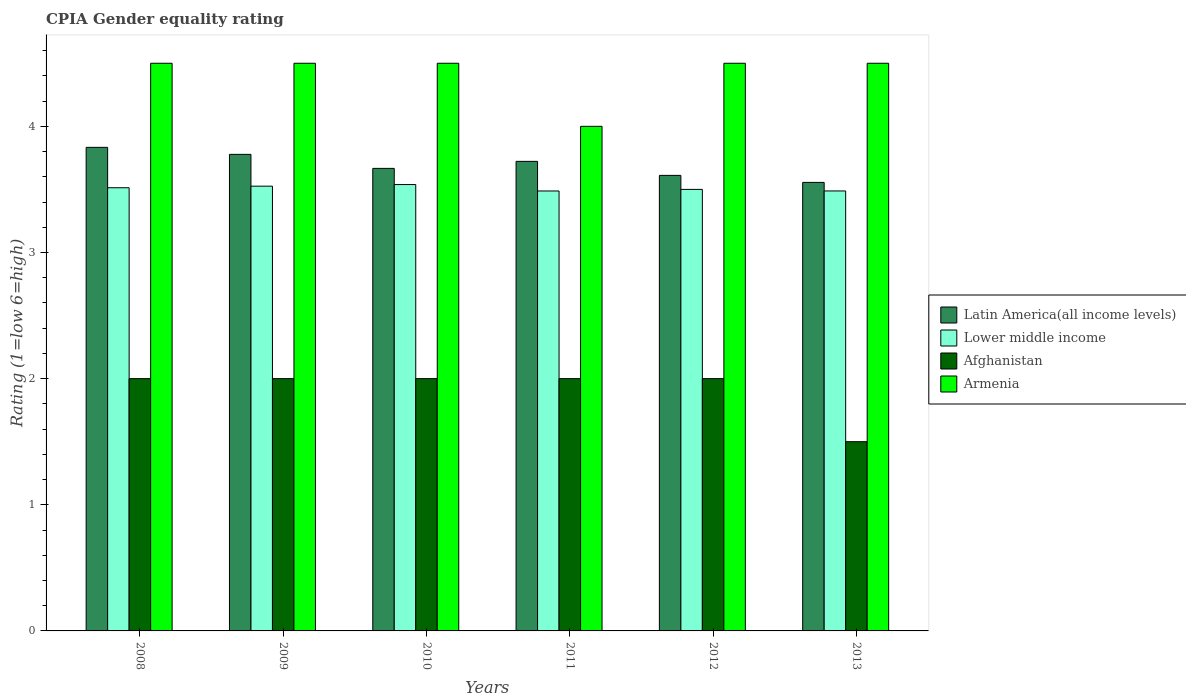How many different coloured bars are there?
Your response must be concise. 4. How many groups of bars are there?
Your answer should be compact. 6. Are the number of bars on each tick of the X-axis equal?
Keep it short and to the point. Yes. How many bars are there on the 4th tick from the left?
Give a very brief answer. 4. How many bars are there on the 4th tick from the right?
Provide a short and direct response. 4. What is the CPIA rating in Latin America(all income levels) in 2009?
Make the answer very short. 3.78. Across all years, what is the maximum CPIA rating in Latin America(all income levels)?
Provide a short and direct response. 3.83. In which year was the CPIA rating in Lower middle income maximum?
Give a very brief answer. 2010. In which year was the CPIA rating in Latin America(all income levels) minimum?
Provide a succinct answer. 2013. What is the total CPIA rating in Afghanistan in the graph?
Provide a succinct answer. 11.5. What is the difference between the CPIA rating in Latin America(all income levels) in 2011 and the CPIA rating in Lower middle income in 2013?
Your answer should be compact. 0.23. What is the average CPIA rating in Armenia per year?
Offer a terse response. 4.42. In the year 2010, what is the difference between the CPIA rating in Latin America(all income levels) and CPIA rating in Afghanistan?
Keep it short and to the point. 1.67. What is the ratio of the CPIA rating in Lower middle income in 2010 to that in 2012?
Your answer should be very brief. 1.01. What is the difference between the highest and the lowest CPIA rating in Afghanistan?
Provide a short and direct response. 0.5. What does the 2nd bar from the left in 2008 represents?
Offer a very short reply. Lower middle income. What does the 2nd bar from the right in 2009 represents?
Your answer should be very brief. Afghanistan. Is it the case that in every year, the sum of the CPIA rating in Lower middle income and CPIA rating in Latin America(all income levels) is greater than the CPIA rating in Armenia?
Provide a succinct answer. Yes. Are all the bars in the graph horizontal?
Make the answer very short. No. What is the difference between two consecutive major ticks on the Y-axis?
Your answer should be very brief. 1. Does the graph contain any zero values?
Your response must be concise. No. Does the graph contain grids?
Keep it short and to the point. No. Where does the legend appear in the graph?
Provide a short and direct response. Center right. How many legend labels are there?
Your response must be concise. 4. What is the title of the graph?
Provide a succinct answer. CPIA Gender equality rating. What is the label or title of the X-axis?
Your response must be concise. Years. What is the Rating (1=low 6=high) in Latin America(all income levels) in 2008?
Your response must be concise. 3.83. What is the Rating (1=low 6=high) of Lower middle income in 2008?
Keep it short and to the point. 3.51. What is the Rating (1=low 6=high) of Armenia in 2008?
Offer a very short reply. 4.5. What is the Rating (1=low 6=high) in Latin America(all income levels) in 2009?
Give a very brief answer. 3.78. What is the Rating (1=low 6=high) in Lower middle income in 2009?
Keep it short and to the point. 3.53. What is the Rating (1=low 6=high) of Armenia in 2009?
Ensure brevity in your answer.  4.5. What is the Rating (1=low 6=high) of Latin America(all income levels) in 2010?
Make the answer very short. 3.67. What is the Rating (1=low 6=high) in Lower middle income in 2010?
Your answer should be very brief. 3.54. What is the Rating (1=low 6=high) of Afghanistan in 2010?
Provide a succinct answer. 2. What is the Rating (1=low 6=high) in Latin America(all income levels) in 2011?
Make the answer very short. 3.72. What is the Rating (1=low 6=high) in Lower middle income in 2011?
Offer a very short reply. 3.49. What is the Rating (1=low 6=high) in Afghanistan in 2011?
Give a very brief answer. 2. What is the Rating (1=low 6=high) of Armenia in 2011?
Make the answer very short. 4. What is the Rating (1=low 6=high) in Latin America(all income levels) in 2012?
Offer a terse response. 3.61. What is the Rating (1=low 6=high) in Lower middle income in 2012?
Your answer should be very brief. 3.5. What is the Rating (1=low 6=high) in Afghanistan in 2012?
Make the answer very short. 2. What is the Rating (1=low 6=high) in Latin America(all income levels) in 2013?
Provide a short and direct response. 3.56. What is the Rating (1=low 6=high) of Lower middle income in 2013?
Ensure brevity in your answer.  3.49. Across all years, what is the maximum Rating (1=low 6=high) of Latin America(all income levels)?
Make the answer very short. 3.83. Across all years, what is the maximum Rating (1=low 6=high) in Lower middle income?
Offer a very short reply. 3.54. Across all years, what is the minimum Rating (1=low 6=high) in Latin America(all income levels)?
Your response must be concise. 3.56. Across all years, what is the minimum Rating (1=low 6=high) in Lower middle income?
Offer a very short reply. 3.49. Across all years, what is the minimum Rating (1=low 6=high) of Armenia?
Keep it short and to the point. 4. What is the total Rating (1=low 6=high) of Latin America(all income levels) in the graph?
Ensure brevity in your answer.  22.17. What is the total Rating (1=low 6=high) of Lower middle income in the graph?
Give a very brief answer. 21.05. What is the difference between the Rating (1=low 6=high) in Latin America(all income levels) in 2008 and that in 2009?
Your answer should be compact. 0.06. What is the difference between the Rating (1=low 6=high) in Lower middle income in 2008 and that in 2009?
Give a very brief answer. -0.01. What is the difference between the Rating (1=low 6=high) in Armenia in 2008 and that in 2009?
Your response must be concise. 0. What is the difference between the Rating (1=low 6=high) in Lower middle income in 2008 and that in 2010?
Give a very brief answer. -0.03. What is the difference between the Rating (1=low 6=high) in Afghanistan in 2008 and that in 2010?
Your answer should be very brief. 0. What is the difference between the Rating (1=low 6=high) in Lower middle income in 2008 and that in 2011?
Your response must be concise. 0.03. What is the difference between the Rating (1=low 6=high) of Latin America(all income levels) in 2008 and that in 2012?
Offer a terse response. 0.22. What is the difference between the Rating (1=low 6=high) of Lower middle income in 2008 and that in 2012?
Provide a short and direct response. 0.01. What is the difference between the Rating (1=low 6=high) in Afghanistan in 2008 and that in 2012?
Your answer should be very brief. 0. What is the difference between the Rating (1=low 6=high) in Latin America(all income levels) in 2008 and that in 2013?
Your answer should be compact. 0.28. What is the difference between the Rating (1=low 6=high) of Lower middle income in 2008 and that in 2013?
Ensure brevity in your answer.  0.03. What is the difference between the Rating (1=low 6=high) in Afghanistan in 2008 and that in 2013?
Make the answer very short. 0.5. What is the difference between the Rating (1=low 6=high) of Latin America(all income levels) in 2009 and that in 2010?
Make the answer very short. 0.11. What is the difference between the Rating (1=low 6=high) of Lower middle income in 2009 and that in 2010?
Provide a short and direct response. -0.01. What is the difference between the Rating (1=low 6=high) in Armenia in 2009 and that in 2010?
Your response must be concise. 0. What is the difference between the Rating (1=low 6=high) in Latin America(all income levels) in 2009 and that in 2011?
Give a very brief answer. 0.06. What is the difference between the Rating (1=low 6=high) of Lower middle income in 2009 and that in 2011?
Give a very brief answer. 0.04. What is the difference between the Rating (1=low 6=high) of Afghanistan in 2009 and that in 2011?
Keep it short and to the point. 0. What is the difference between the Rating (1=low 6=high) of Latin America(all income levels) in 2009 and that in 2012?
Ensure brevity in your answer.  0.17. What is the difference between the Rating (1=low 6=high) in Lower middle income in 2009 and that in 2012?
Your answer should be very brief. 0.03. What is the difference between the Rating (1=low 6=high) of Armenia in 2009 and that in 2012?
Offer a terse response. 0. What is the difference between the Rating (1=low 6=high) of Latin America(all income levels) in 2009 and that in 2013?
Your answer should be very brief. 0.22. What is the difference between the Rating (1=low 6=high) in Lower middle income in 2009 and that in 2013?
Your response must be concise. 0.04. What is the difference between the Rating (1=low 6=high) of Afghanistan in 2009 and that in 2013?
Provide a succinct answer. 0.5. What is the difference between the Rating (1=low 6=high) in Armenia in 2009 and that in 2013?
Keep it short and to the point. 0. What is the difference between the Rating (1=low 6=high) of Latin America(all income levels) in 2010 and that in 2011?
Provide a short and direct response. -0.06. What is the difference between the Rating (1=low 6=high) of Lower middle income in 2010 and that in 2011?
Provide a short and direct response. 0.05. What is the difference between the Rating (1=low 6=high) in Armenia in 2010 and that in 2011?
Provide a short and direct response. 0.5. What is the difference between the Rating (1=low 6=high) in Latin America(all income levels) in 2010 and that in 2012?
Provide a succinct answer. 0.06. What is the difference between the Rating (1=low 6=high) in Lower middle income in 2010 and that in 2012?
Offer a very short reply. 0.04. What is the difference between the Rating (1=low 6=high) of Afghanistan in 2010 and that in 2012?
Give a very brief answer. 0. What is the difference between the Rating (1=low 6=high) in Lower middle income in 2010 and that in 2013?
Offer a very short reply. 0.05. What is the difference between the Rating (1=low 6=high) in Armenia in 2010 and that in 2013?
Give a very brief answer. 0. What is the difference between the Rating (1=low 6=high) in Latin America(all income levels) in 2011 and that in 2012?
Provide a short and direct response. 0.11. What is the difference between the Rating (1=low 6=high) of Lower middle income in 2011 and that in 2012?
Keep it short and to the point. -0.01. What is the difference between the Rating (1=low 6=high) in Armenia in 2011 and that in 2012?
Make the answer very short. -0.5. What is the difference between the Rating (1=low 6=high) in Latin America(all income levels) in 2011 and that in 2013?
Your response must be concise. 0.17. What is the difference between the Rating (1=low 6=high) in Lower middle income in 2011 and that in 2013?
Ensure brevity in your answer.  -0. What is the difference between the Rating (1=low 6=high) of Afghanistan in 2011 and that in 2013?
Offer a very short reply. 0.5. What is the difference between the Rating (1=low 6=high) in Latin America(all income levels) in 2012 and that in 2013?
Give a very brief answer. 0.06. What is the difference between the Rating (1=low 6=high) in Lower middle income in 2012 and that in 2013?
Give a very brief answer. 0.01. What is the difference between the Rating (1=low 6=high) of Afghanistan in 2012 and that in 2013?
Offer a very short reply. 0.5. What is the difference between the Rating (1=low 6=high) of Latin America(all income levels) in 2008 and the Rating (1=low 6=high) of Lower middle income in 2009?
Ensure brevity in your answer.  0.31. What is the difference between the Rating (1=low 6=high) in Latin America(all income levels) in 2008 and the Rating (1=low 6=high) in Afghanistan in 2009?
Provide a short and direct response. 1.83. What is the difference between the Rating (1=low 6=high) in Lower middle income in 2008 and the Rating (1=low 6=high) in Afghanistan in 2009?
Your response must be concise. 1.51. What is the difference between the Rating (1=low 6=high) in Lower middle income in 2008 and the Rating (1=low 6=high) in Armenia in 2009?
Your answer should be very brief. -0.99. What is the difference between the Rating (1=low 6=high) of Latin America(all income levels) in 2008 and the Rating (1=low 6=high) of Lower middle income in 2010?
Ensure brevity in your answer.  0.29. What is the difference between the Rating (1=low 6=high) in Latin America(all income levels) in 2008 and the Rating (1=low 6=high) in Afghanistan in 2010?
Ensure brevity in your answer.  1.83. What is the difference between the Rating (1=low 6=high) in Lower middle income in 2008 and the Rating (1=low 6=high) in Afghanistan in 2010?
Give a very brief answer. 1.51. What is the difference between the Rating (1=low 6=high) in Lower middle income in 2008 and the Rating (1=low 6=high) in Armenia in 2010?
Make the answer very short. -0.99. What is the difference between the Rating (1=low 6=high) in Latin America(all income levels) in 2008 and the Rating (1=low 6=high) in Lower middle income in 2011?
Your answer should be compact. 0.35. What is the difference between the Rating (1=low 6=high) of Latin America(all income levels) in 2008 and the Rating (1=low 6=high) of Afghanistan in 2011?
Provide a succinct answer. 1.83. What is the difference between the Rating (1=low 6=high) of Latin America(all income levels) in 2008 and the Rating (1=low 6=high) of Armenia in 2011?
Make the answer very short. -0.17. What is the difference between the Rating (1=low 6=high) in Lower middle income in 2008 and the Rating (1=low 6=high) in Afghanistan in 2011?
Give a very brief answer. 1.51. What is the difference between the Rating (1=low 6=high) of Lower middle income in 2008 and the Rating (1=low 6=high) of Armenia in 2011?
Your answer should be compact. -0.49. What is the difference between the Rating (1=low 6=high) of Afghanistan in 2008 and the Rating (1=low 6=high) of Armenia in 2011?
Provide a short and direct response. -2. What is the difference between the Rating (1=low 6=high) in Latin America(all income levels) in 2008 and the Rating (1=low 6=high) in Lower middle income in 2012?
Keep it short and to the point. 0.33. What is the difference between the Rating (1=low 6=high) in Latin America(all income levels) in 2008 and the Rating (1=low 6=high) in Afghanistan in 2012?
Ensure brevity in your answer.  1.83. What is the difference between the Rating (1=low 6=high) of Lower middle income in 2008 and the Rating (1=low 6=high) of Afghanistan in 2012?
Keep it short and to the point. 1.51. What is the difference between the Rating (1=low 6=high) in Lower middle income in 2008 and the Rating (1=low 6=high) in Armenia in 2012?
Your answer should be compact. -0.99. What is the difference between the Rating (1=low 6=high) in Afghanistan in 2008 and the Rating (1=low 6=high) in Armenia in 2012?
Offer a terse response. -2.5. What is the difference between the Rating (1=low 6=high) of Latin America(all income levels) in 2008 and the Rating (1=low 6=high) of Lower middle income in 2013?
Your answer should be very brief. 0.35. What is the difference between the Rating (1=low 6=high) of Latin America(all income levels) in 2008 and the Rating (1=low 6=high) of Afghanistan in 2013?
Give a very brief answer. 2.33. What is the difference between the Rating (1=low 6=high) in Latin America(all income levels) in 2008 and the Rating (1=low 6=high) in Armenia in 2013?
Give a very brief answer. -0.67. What is the difference between the Rating (1=low 6=high) of Lower middle income in 2008 and the Rating (1=low 6=high) of Afghanistan in 2013?
Your answer should be compact. 2.01. What is the difference between the Rating (1=low 6=high) of Lower middle income in 2008 and the Rating (1=low 6=high) of Armenia in 2013?
Provide a short and direct response. -0.99. What is the difference between the Rating (1=low 6=high) of Afghanistan in 2008 and the Rating (1=low 6=high) of Armenia in 2013?
Offer a very short reply. -2.5. What is the difference between the Rating (1=low 6=high) of Latin America(all income levels) in 2009 and the Rating (1=low 6=high) of Lower middle income in 2010?
Ensure brevity in your answer.  0.24. What is the difference between the Rating (1=low 6=high) in Latin America(all income levels) in 2009 and the Rating (1=low 6=high) in Afghanistan in 2010?
Provide a short and direct response. 1.78. What is the difference between the Rating (1=low 6=high) of Latin America(all income levels) in 2009 and the Rating (1=low 6=high) of Armenia in 2010?
Your response must be concise. -0.72. What is the difference between the Rating (1=low 6=high) of Lower middle income in 2009 and the Rating (1=low 6=high) of Afghanistan in 2010?
Your answer should be very brief. 1.53. What is the difference between the Rating (1=low 6=high) in Lower middle income in 2009 and the Rating (1=low 6=high) in Armenia in 2010?
Your response must be concise. -0.97. What is the difference between the Rating (1=low 6=high) in Latin America(all income levels) in 2009 and the Rating (1=low 6=high) in Lower middle income in 2011?
Make the answer very short. 0.29. What is the difference between the Rating (1=low 6=high) in Latin America(all income levels) in 2009 and the Rating (1=low 6=high) in Afghanistan in 2011?
Offer a terse response. 1.78. What is the difference between the Rating (1=low 6=high) in Latin America(all income levels) in 2009 and the Rating (1=low 6=high) in Armenia in 2011?
Give a very brief answer. -0.22. What is the difference between the Rating (1=low 6=high) of Lower middle income in 2009 and the Rating (1=low 6=high) of Afghanistan in 2011?
Make the answer very short. 1.53. What is the difference between the Rating (1=low 6=high) of Lower middle income in 2009 and the Rating (1=low 6=high) of Armenia in 2011?
Keep it short and to the point. -0.47. What is the difference between the Rating (1=low 6=high) in Latin America(all income levels) in 2009 and the Rating (1=low 6=high) in Lower middle income in 2012?
Your response must be concise. 0.28. What is the difference between the Rating (1=low 6=high) of Latin America(all income levels) in 2009 and the Rating (1=low 6=high) of Afghanistan in 2012?
Your response must be concise. 1.78. What is the difference between the Rating (1=low 6=high) of Latin America(all income levels) in 2009 and the Rating (1=low 6=high) of Armenia in 2012?
Your response must be concise. -0.72. What is the difference between the Rating (1=low 6=high) in Lower middle income in 2009 and the Rating (1=low 6=high) in Afghanistan in 2012?
Offer a terse response. 1.53. What is the difference between the Rating (1=low 6=high) in Lower middle income in 2009 and the Rating (1=low 6=high) in Armenia in 2012?
Keep it short and to the point. -0.97. What is the difference between the Rating (1=low 6=high) of Latin America(all income levels) in 2009 and the Rating (1=low 6=high) of Lower middle income in 2013?
Make the answer very short. 0.29. What is the difference between the Rating (1=low 6=high) of Latin America(all income levels) in 2009 and the Rating (1=low 6=high) of Afghanistan in 2013?
Keep it short and to the point. 2.28. What is the difference between the Rating (1=low 6=high) of Latin America(all income levels) in 2009 and the Rating (1=low 6=high) of Armenia in 2013?
Offer a very short reply. -0.72. What is the difference between the Rating (1=low 6=high) of Lower middle income in 2009 and the Rating (1=low 6=high) of Afghanistan in 2013?
Ensure brevity in your answer.  2.03. What is the difference between the Rating (1=low 6=high) in Lower middle income in 2009 and the Rating (1=low 6=high) in Armenia in 2013?
Your answer should be compact. -0.97. What is the difference between the Rating (1=low 6=high) in Latin America(all income levels) in 2010 and the Rating (1=low 6=high) in Lower middle income in 2011?
Your response must be concise. 0.18. What is the difference between the Rating (1=low 6=high) of Latin America(all income levels) in 2010 and the Rating (1=low 6=high) of Afghanistan in 2011?
Offer a very short reply. 1.67. What is the difference between the Rating (1=low 6=high) of Latin America(all income levels) in 2010 and the Rating (1=low 6=high) of Armenia in 2011?
Give a very brief answer. -0.33. What is the difference between the Rating (1=low 6=high) in Lower middle income in 2010 and the Rating (1=low 6=high) in Afghanistan in 2011?
Make the answer very short. 1.54. What is the difference between the Rating (1=low 6=high) of Lower middle income in 2010 and the Rating (1=low 6=high) of Armenia in 2011?
Your answer should be very brief. -0.46. What is the difference between the Rating (1=low 6=high) of Latin America(all income levels) in 2010 and the Rating (1=low 6=high) of Afghanistan in 2012?
Make the answer very short. 1.67. What is the difference between the Rating (1=low 6=high) in Lower middle income in 2010 and the Rating (1=low 6=high) in Afghanistan in 2012?
Provide a succinct answer. 1.54. What is the difference between the Rating (1=low 6=high) in Lower middle income in 2010 and the Rating (1=low 6=high) in Armenia in 2012?
Provide a succinct answer. -0.96. What is the difference between the Rating (1=low 6=high) of Latin America(all income levels) in 2010 and the Rating (1=low 6=high) of Lower middle income in 2013?
Offer a very short reply. 0.18. What is the difference between the Rating (1=low 6=high) in Latin America(all income levels) in 2010 and the Rating (1=low 6=high) in Afghanistan in 2013?
Your answer should be very brief. 2.17. What is the difference between the Rating (1=low 6=high) in Latin America(all income levels) in 2010 and the Rating (1=low 6=high) in Armenia in 2013?
Keep it short and to the point. -0.83. What is the difference between the Rating (1=low 6=high) of Lower middle income in 2010 and the Rating (1=low 6=high) of Afghanistan in 2013?
Keep it short and to the point. 2.04. What is the difference between the Rating (1=low 6=high) in Lower middle income in 2010 and the Rating (1=low 6=high) in Armenia in 2013?
Offer a terse response. -0.96. What is the difference between the Rating (1=low 6=high) of Latin America(all income levels) in 2011 and the Rating (1=low 6=high) of Lower middle income in 2012?
Provide a succinct answer. 0.22. What is the difference between the Rating (1=low 6=high) of Latin America(all income levels) in 2011 and the Rating (1=low 6=high) of Afghanistan in 2012?
Your answer should be compact. 1.72. What is the difference between the Rating (1=low 6=high) in Latin America(all income levels) in 2011 and the Rating (1=low 6=high) in Armenia in 2012?
Give a very brief answer. -0.78. What is the difference between the Rating (1=low 6=high) in Lower middle income in 2011 and the Rating (1=low 6=high) in Afghanistan in 2012?
Keep it short and to the point. 1.49. What is the difference between the Rating (1=low 6=high) in Lower middle income in 2011 and the Rating (1=low 6=high) in Armenia in 2012?
Offer a terse response. -1.01. What is the difference between the Rating (1=low 6=high) of Afghanistan in 2011 and the Rating (1=low 6=high) of Armenia in 2012?
Your answer should be compact. -2.5. What is the difference between the Rating (1=low 6=high) of Latin America(all income levels) in 2011 and the Rating (1=low 6=high) of Lower middle income in 2013?
Offer a very short reply. 0.23. What is the difference between the Rating (1=low 6=high) in Latin America(all income levels) in 2011 and the Rating (1=low 6=high) in Afghanistan in 2013?
Ensure brevity in your answer.  2.22. What is the difference between the Rating (1=low 6=high) of Latin America(all income levels) in 2011 and the Rating (1=low 6=high) of Armenia in 2013?
Ensure brevity in your answer.  -0.78. What is the difference between the Rating (1=low 6=high) in Lower middle income in 2011 and the Rating (1=low 6=high) in Afghanistan in 2013?
Ensure brevity in your answer.  1.99. What is the difference between the Rating (1=low 6=high) in Lower middle income in 2011 and the Rating (1=low 6=high) in Armenia in 2013?
Your answer should be compact. -1.01. What is the difference between the Rating (1=low 6=high) of Afghanistan in 2011 and the Rating (1=low 6=high) of Armenia in 2013?
Offer a very short reply. -2.5. What is the difference between the Rating (1=low 6=high) of Latin America(all income levels) in 2012 and the Rating (1=low 6=high) of Lower middle income in 2013?
Your answer should be compact. 0.12. What is the difference between the Rating (1=low 6=high) in Latin America(all income levels) in 2012 and the Rating (1=low 6=high) in Afghanistan in 2013?
Provide a short and direct response. 2.11. What is the difference between the Rating (1=low 6=high) in Latin America(all income levels) in 2012 and the Rating (1=low 6=high) in Armenia in 2013?
Your answer should be very brief. -0.89. What is the difference between the Rating (1=low 6=high) of Lower middle income in 2012 and the Rating (1=low 6=high) of Afghanistan in 2013?
Your answer should be very brief. 2. What is the difference between the Rating (1=low 6=high) of Lower middle income in 2012 and the Rating (1=low 6=high) of Armenia in 2013?
Your answer should be very brief. -1. What is the average Rating (1=low 6=high) in Latin America(all income levels) per year?
Ensure brevity in your answer.  3.69. What is the average Rating (1=low 6=high) in Lower middle income per year?
Ensure brevity in your answer.  3.51. What is the average Rating (1=low 6=high) of Afghanistan per year?
Your answer should be compact. 1.92. What is the average Rating (1=low 6=high) in Armenia per year?
Your answer should be very brief. 4.42. In the year 2008, what is the difference between the Rating (1=low 6=high) of Latin America(all income levels) and Rating (1=low 6=high) of Lower middle income?
Provide a succinct answer. 0.32. In the year 2008, what is the difference between the Rating (1=low 6=high) of Latin America(all income levels) and Rating (1=low 6=high) of Afghanistan?
Provide a short and direct response. 1.83. In the year 2008, what is the difference between the Rating (1=low 6=high) of Lower middle income and Rating (1=low 6=high) of Afghanistan?
Your response must be concise. 1.51. In the year 2008, what is the difference between the Rating (1=low 6=high) in Lower middle income and Rating (1=low 6=high) in Armenia?
Ensure brevity in your answer.  -0.99. In the year 2008, what is the difference between the Rating (1=low 6=high) in Afghanistan and Rating (1=low 6=high) in Armenia?
Offer a very short reply. -2.5. In the year 2009, what is the difference between the Rating (1=low 6=high) in Latin America(all income levels) and Rating (1=low 6=high) in Lower middle income?
Make the answer very short. 0.25. In the year 2009, what is the difference between the Rating (1=low 6=high) in Latin America(all income levels) and Rating (1=low 6=high) in Afghanistan?
Your response must be concise. 1.78. In the year 2009, what is the difference between the Rating (1=low 6=high) in Latin America(all income levels) and Rating (1=low 6=high) in Armenia?
Give a very brief answer. -0.72. In the year 2009, what is the difference between the Rating (1=low 6=high) in Lower middle income and Rating (1=low 6=high) in Afghanistan?
Provide a succinct answer. 1.53. In the year 2009, what is the difference between the Rating (1=low 6=high) of Lower middle income and Rating (1=low 6=high) of Armenia?
Your answer should be very brief. -0.97. In the year 2009, what is the difference between the Rating (1=low 6=high) of Afghanistan and Rating (1=low 6=high) of Armenia?
Your answer should be very brief. -2.5. In the year 2010, what is the difference between the Rating (1=low 6=high) in Latin America(all income levels) and Rating (1=low 6=high) in Lower middle income?
Ensure brevity in your answer.  0.13. In the year 2010, what is the difference between the Rating (1=low 6=high) in Latin America(all income levels) and Rating (1=low 6=high) in Armenia?
Provide a succinct answer. -0.83. In the year 2010, what is the difference between the Rating (1=low 6=high) in Lower middle income and Rating (1=low 6=high) in Afghanistan?
Your response must be concise. 1.54. In the year 2010, what is the difference between the Rating (1=low 6=high) of Lower middle income and Rating (1=low 6=high) of Armenia?
Ensure brevity in your answer.  -0.96. In the year 2011, what is the difference between the Rating (1=low 6=high) of Latin America(all income levels) and Rating (1=low 6=high) of Lower middle income?
Your answer should be compact. 0.23. In the year 2011, what is the difference between the Rating (1=low 6=high) of Latin America(all income levels) and Rating (1=low 6=high) of Afghanistan?
Keep it short and to the point. 1.72. In the year 2011, what is the difference between the Rating (1=low 6=high) of Latin America(all income levels) and Rating (1=low 6=high) of Armenia?
Offer a terse response. -0.28. In the year 2011, what is the difference between the Rating (1=low 6=high) in Lower middle income and Rating (1=low 6=high) in Afghanistan?
Offer a terse response. 1.49. In the year 2011, what is the difference between the Rating (1=low 6=high) of Lower middle income and Rating (1=low 6=high) of Armenia?
Keep it short and to the point. -0.51. In the year 2011, what is the difference between the Rating (1=low 6=high) of Afghanistan and Rating (1=low 6=high) of Armenia?
Offer a very short reply. -2. In the year 2012, what is the difference between the Rating (1=low 6=high) in Latin America(all income levels) and Rating (1=low 6=high) in Afghanistan?
Keep it short and to the point. 1.61. In the year 2012, what is the difference between the Rating (1=low 6=high) in Latin America(all income levels) and Rating (1=low 6=high) in Armenia?
Offer a very short reply. -0.89. In the year 2012, what is the difference between the Rating (1=low 6=high) of Lower middle income and Rating (1=low 6=high) of Afghanistan?
Give a very brief answer. 1.5. In the year 2012, what is the difference between the Rating (1=low 6=high) in Lower middle income and Rating (1=low 6=high) in Armenia?
Offer a terse response. -1. In the year 2013, what is the difference between the Rating (1=low 6=high) in Latin America(all income levels) and Rating (1=low 6=high) in Lower middle income?
Offer a very short reply. 0.07. In the year 2013, what is the difference between the Rating (1=low 6=high) in Latin America(all income levels) and Rating (1=low 6=high) in Afghanistan?
Your response must be concise. 2.06. In the year 2013, what is the difference between the Rating (1=low 6=high) in Latin America(all income levels) and Rating (1=low 6=high) in Armenia?
Make the answer very short. -0.94. In the year 2013, what is the difference between the Rating (1=low 6=high) of Lower middle income and Rating (1=low 6=high) of Afghanistan?
Offer a very short reply. 1.99. In the year 2013, what is the difference between the Rating (1=low 6=high) in Lower middle income and Rating (1=low 6=high) in Armenia?
Your answer should be very brief. -1.01. In the year 2013, what is the difference between the Rating (1=low 6=high) in Afghanistan and Rating (1=low 6=high) in Armenia?
Ensure brevity in your answer.  -3. What is the ratio of the Rating (1=low 6=high) of Latin America(all income levels) in 2008 to that in 2009?
Your answer should be very brief. 1.01. What is the ratio of the Rating (1=low 6=high) in Afghanistan in 2008 to that in 2009?
Give a very brief answer. 1. What is the ratio of the Rating (1=low 6=high) in Armenia in 2008 to that in 2009?
Give a very brief answer. 1. What is the ratio of the Rating (1=low 6=high) of Latin America(all income levels) in 2008 to that in 2010?
Your answer should be very brief. 1.05. What is the ratio of the Rating (1=low 6=high) of Afghanistan in 2008 to that in 2010?
Offer a terse response. 1. What is the ratio of the Rating (1=low 6=high) in Armenia in 2008 to that in 2010?
Give a very brief answer. 1. What is the ratio of the Rating (1=low 6=high) of Latin America(all income levels) in 2008 to that in 2011?
Make the answer very short. 1.03. What is the ratio of the Rating (1=low 6=high) in Lower middle income in 2008 to that in 2011?
Offer a terse response. 1.01. What is the ratio of the Rating (1=low 6=high) in Afghanistan in 2008 to that in 2011?
Offer a very short reply. 1. What is the ratio of the Rating (1=low 6=high) of Armenia in 2008 to that in 2011?
Give a very brief answer. 1.12. What is the ratio of the Rating (1=low 6=high) of Latin America(all income levels) in 2008 to that in 2012?
Keep it short and to the point. 1.06. What is the ratio of the Rating (1=low 6=high) in Lower middle income in 2008 to that in 2012?
Your answer should be very brief. 1. What is the ratio of the Rating (1=low 6=high) in Armenia in 2008 to that in 2012?
Your response must be concise. 1. What is the ratio of the Rating (1=low 6=high) of Latin America(all income levels) in 2008 to that in 2013?
Give a very brief answer. 1.08. What is the ratio of the Rating (1=low 6=high) of Lower middle income in 2008 to that in 2013?
Your response must be concise. 1.01. What is the ratio of the Rating (1=low 6=high) of Latin America(all income levels) in 2009 to that in 2010?
Provide a short and direct response. 1.03. What is the ratio of the Rating (1=low 6=high) of Lower middle income in 2009 to that in 2010?
Your response must be concise. 1. What is the ratio of the Rating (1=low 6=high) in Armenia in 2009 to that in 2010?
Your response must be concise. 1. What is the ratio of the Rating (1=low 6=high) in Latin America(all income levels) in 2009 to that in 2011?
Keep it short and to the point. 1.01. What is the ratio of the Rating (1=low 6=high) of Lower middle income in 2009 to that in 2011?
Ensure brevity in your answer.  1.01. What is the ratio of the Rating (1=low 6=high) in Afghanistan in 2009 to that in 2011?
Keep it short and to the point. 1. What is the ratio of the Rating (1=low 6=high) of Latin America(all income levels) in 2009 to that in 2012?
Provide a short and direct response. 1.05. What is the ratio of the Rating (1=low 6=high) of Lower middle income in 2009 to that in 2012?
Your answer should be very brief. 1.01. What is the ratio of the Rating (1=low 6=high) in Latin America(all income levels) in 2009 to that in 2013?
Offer a very short reply. 1.06. What is the ratio of the Rating (1=low 6=high) in Lower middle income in 2009 to that in 2013?
Make the answer very short. 1.01. What is the ratio of the Rating (1=low 6=high) in Armenia in 2009 to that in 2013?
Provide a succinct answer. 1. What is the ratio of the Rating (1=low 6=high) of Latin America(all income levels) in 2010 to that in 2011?
Your response must be concise. 0.99. What is the ratio of the Rating (1=low 6=high) of Lower middle income in 2010 to that in 2011?
Offer a very short reply. 1.01. What is the ratio of the Rating (1=low 6=high) of Afghanistan in 2010 to that in 2011?
Offer a very short reply. 1. What is the ratio of the Rating (1=low 6=high) in Latin America(all income levels) in 2010 to that in 2012?
Make the answer very short. 1.02. What is the ratio of the Rating (1=low 6=high) in Lower middle income in 2010 to that in 2012?
Offer a terse response. 1.01. What is the ratio of the Rating (1=low 6=high) of Afghanistan in 2010 to that in 2012?
Your answer should be very brief. 1. What is the ratio of the Rating (1=low 6=high) in Latin America(all income levels) in 2010 to that in 2013?
Your answer should be very brief. 1.03. What is the ratio of the Rating (1=low 6=high) in Lower middle income in 2010 to that in 2013?
Provide a short and direct response. 1.01. What is the ratio of the Rating (1=low 6=high) of Latin America(all income levels) in 2011 to that in 2012?
Provide a short and direct response. 1.03. What is the ratio of the Rating (1=low 6=high) of Lower middle income in 2011 to that in 2012?
Your answer should be very brief. 1. What is the ratio of the Rating (1=low 6=high) in Armenia in 2011 to that in 2012?
Offer a terse response. 0.89. What is the ratio of the Rating (1=low 6=high) in Latin America(all income levels) in 2011 to that in 2013?
Give a very brief answer. 1.05. What is the ratio of the Rating (1=low 6=high) in Latin America(all income levels) in 2012 to that in 2013?
Make the answer very short. 1.02. What is the ratio of the Rating (1=low 6=high) in Afghanistan in 2012 to that in 2013?
Provide a succinct answer. 1.33. What is the ratio of the Rating (1=low 6=high) of Armenia in 2012 to that in 2013?
Your answer should be compact. 1. What is the difference between the highest and the second highest Rating (1=low 6=high) of Latin America(all income levels)?
Your response must be concise. 0.06. What is the difference between the highest and the second highest Rating (1=low 6=high) in Lower middle income?
Provide a short and direct response. 0.01. What is the difference between the highest and the lowest Rating (1=low 6=high) in Latin America(all income levels)?
Offer a very short reply. 0.28. What is the difference between the highest and the lowest Rating (1=low 6=high) of Lower middle income?
Provide a short and direct response. 0.05. What is the difference between the highest and the lowest Rating (1=low 6=high) of Armenia?
Ensure brevity in your answer.  0.5. 